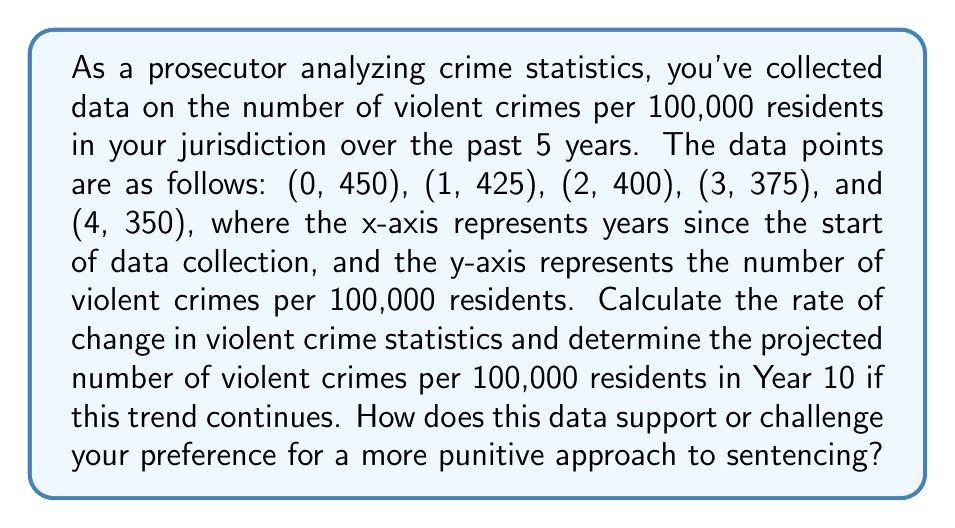What is the answer to this math problem? To solve this problem, we'll follow these steps:

1. Plot the given points on a coordinate system.
2. Determine the linear equation that best fits the data.
3. Calculate the rate of change (slope) of the line.
4. Use the equation to project the crime rate for Year 10.

Step 1: Plotting the points
We can visualize the data points on a coordinate system:

[asy]
size(200,200);
real[] x = {0,1,2,3,4};
real[] y = {450,425,400,375,350};
for(int i=0; i<5; ++i) {
  dot((x[i],y[i]));
}
xaxis("Years",0,5,1);
yaxis("Crimes per 100,000",300,500,50);
label("(0,450)",(0,450),NW);
label("(4,350)",(4,350),SE);
[/asy]

Step 2: Determining the linear equation
The linear equation has the form $y = mx + b$, where $m$ is the slope and $b$ is the y-intercept.

To find the slope, we can use the first and last points:
$$m = \frac{y_2 - y_1}{x_2 - x_1} = \frac{350 - 450}{4 - 0} = -\frac{100}{4} = -25$$

The y-intercept is given by the first point (0, 450), so $b = 450$.

Therefore, the linear equation is:
$$y = -25x + 450$$

Step 3: Calculating the rate of change
The rate of change is the slope of the line, which we calculated as -25. This means that the violent crime rate is decreasing by 25 crimes per 100,000 residents each year.

Step 4: Projecting the crime rate for Year 10
To find the projected crime rate for Year 10, we substitute x = 10 into our equation:

$$y = -25(10) + 450 = -250 + 450 = 200$$

Therefore, the projected number of violent crimes per 100,000 residents in Year 10 is 200.

This data shows a consistent decrease in violent crime rates over time. As a prosecutor preferring a more punitive approach, you might argue that this decline is due to strict sentencing deterring potential offenders. However, it's important to note that this data alone doesn't prove causation, and other factors could be contributing to the decrease in crime rates.
Answer: The rate of change in violent crime statistics is -25 crimes per 100,000 residents per year. The projected number of violent crimes per 100,000 residents in Year 10 is 200. 